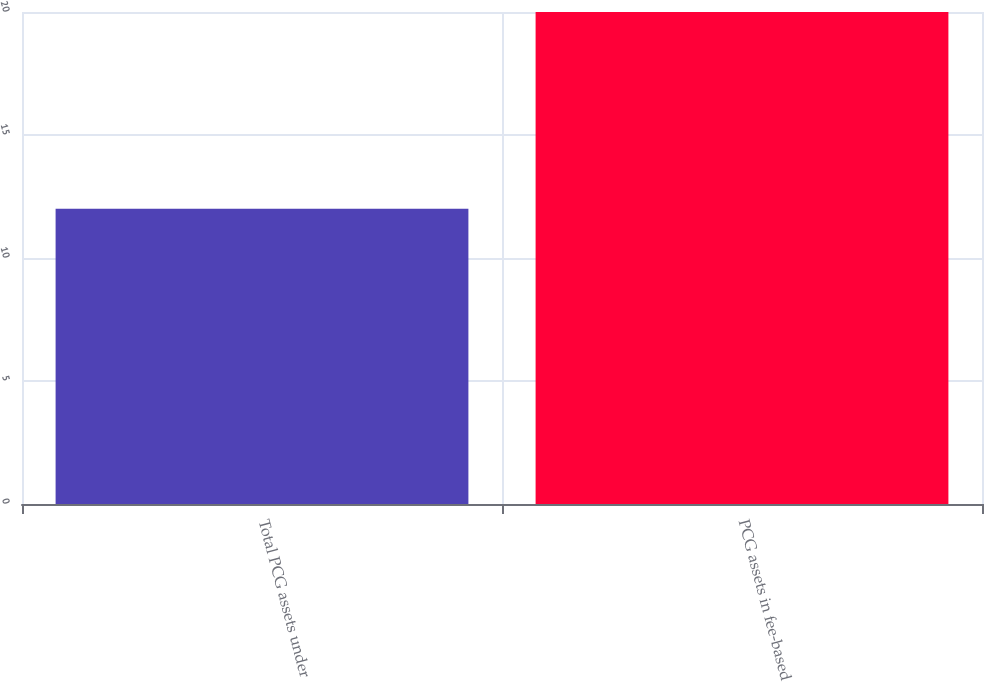Convert chart to OTSL. <chart><loc_0><loc_0><loc_500><loc_500><bar_chart><fcel>Total PCG assets under<fcel>PCG assets in fee-based<nl><fcel>12<fcel>20<nl></chart> 